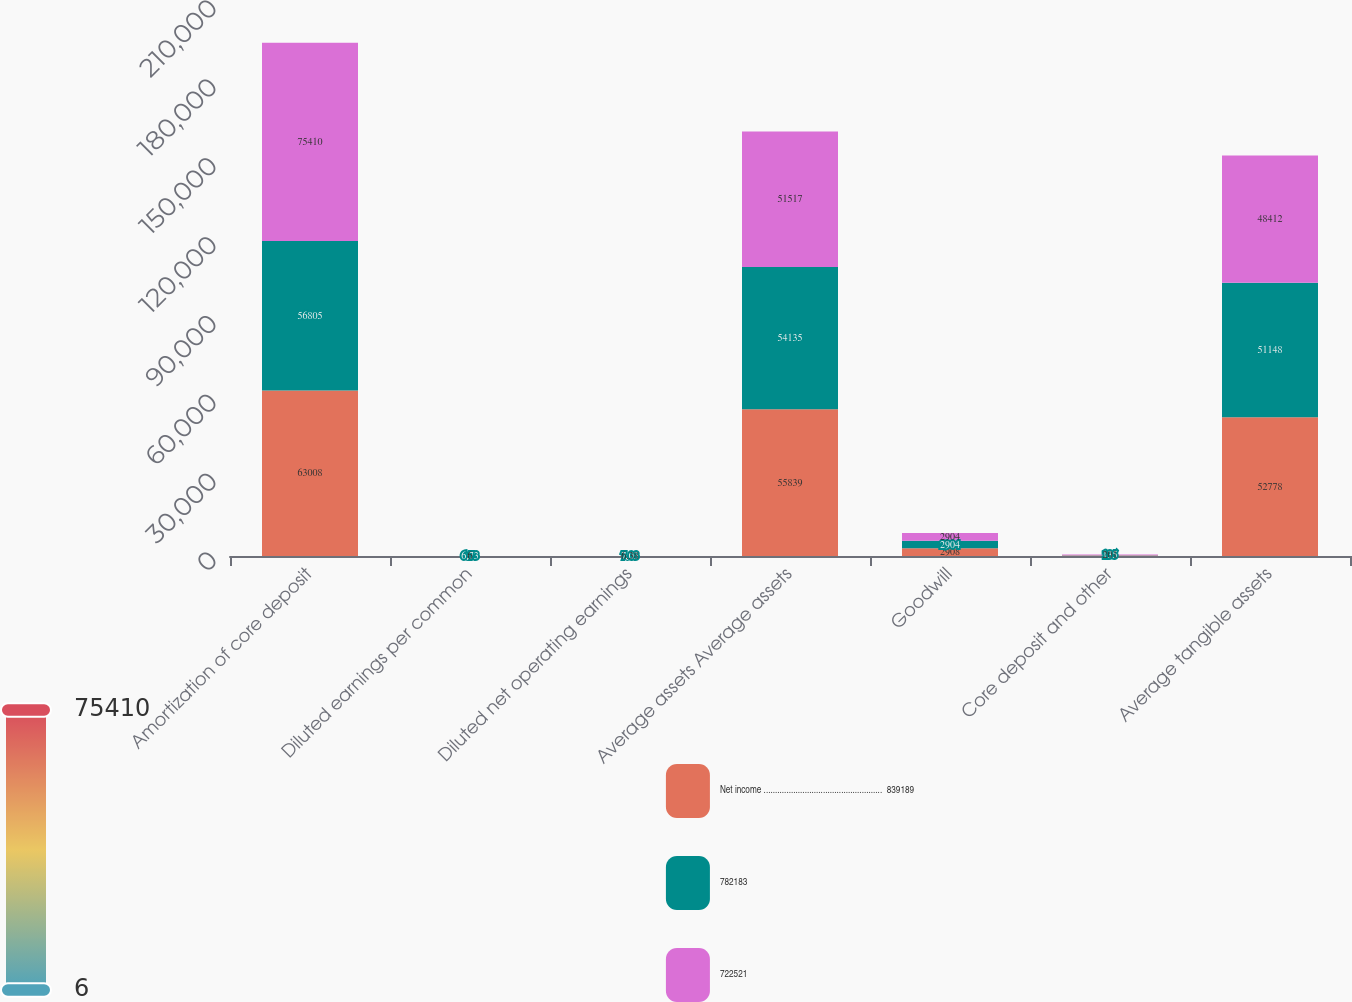<chart> <loc_0><loc_0><loc_500><loc_500><stacked_bar_chart><ecel><fcel>Amortization of core deposit<fcel>Diluted earnings per common<fcel>Diluted net operating earnings<fcel>Average assets Average assets<fcel>Goodwill<fcel>Core deposit and other<fcel>Average tangible assets<nl><fcel>Net income ....................................................  839189<fcel>63008<fcel>7.37<fcel>7.73<fcel>55839<fcel>2908<fcel>191<fcel>52778<nl><fcel>782183<fcel>56805<fcel>6.73<fcel>7.03<fcel>54135<fcel>2904<fcel>135<fcel>51148<nl><fcel>722521<fcel>75410<fcel>6<fcel>6.38<fcel>51517<fcel>2904<fcel>201<fcel>48412<nl></chart> 